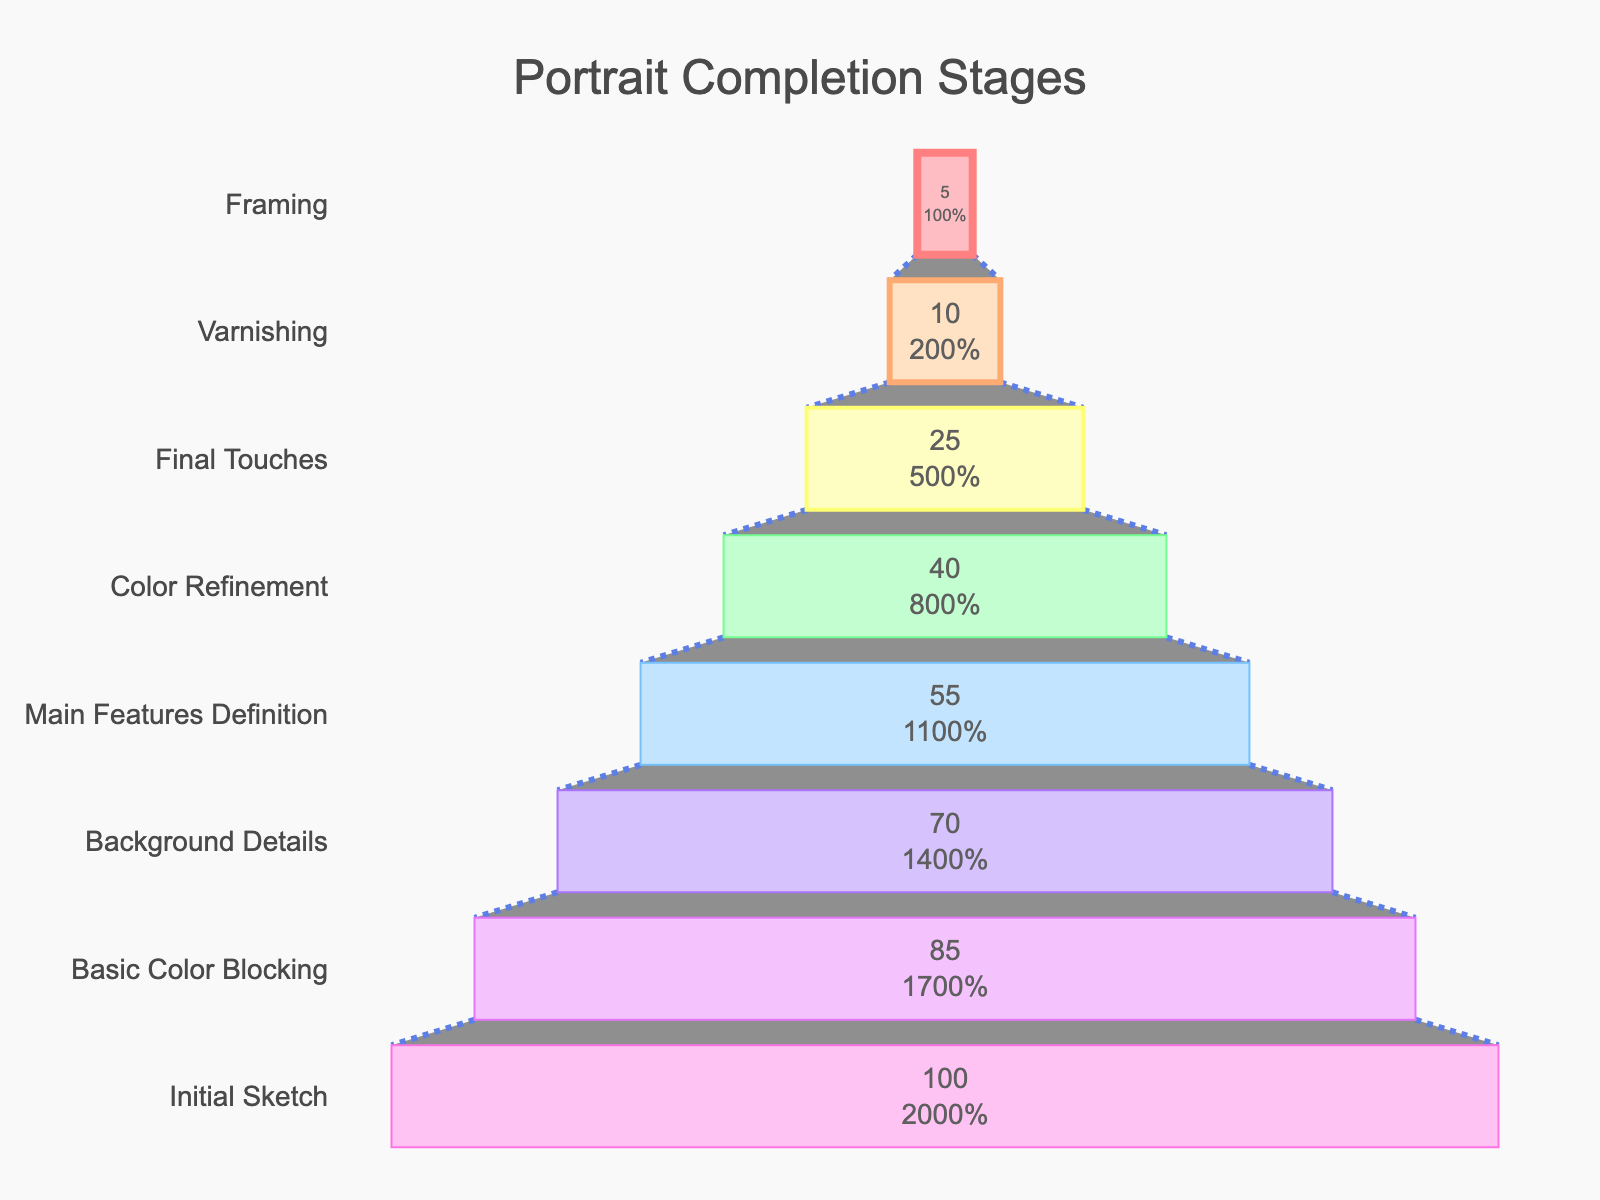How many stages are there in the portrait completion process? The funnel chart lists different stages starting from "Initial Sketch" to "Framing". Count each stage.
Answer: 8 Which stage has the highest percentage completed? The stage with the highest percentage completed is the one at the top of the funnel, labeled "Initial Sketch" with 100% completed.
Answer: Initial Sketch At which stage is the completion percentage closest to 50%? Look at the list of stages and their corresponding completion percentages. The "Main Features Definition" stage has a completion percentage of 55%, which is closest to 50%.
Answer: Main Features Definition How much is the completion percentage reduced from the "Background Details" stage to the "Main Features Definition" stage? The completion percentage at the "Background Details" stage is 70%, and at "Main Features Definition" it is 55%. Subtract 55 from 70 to find the difference.
Answer: 15% Which stage experiences the smallest drop in percentage completion from the previous stage? Compare the percentage drops between each consecutive stage. The drop between "Final Touches" (25%) and "Varnishing" (10%) is the smallest, which is 15%.
Answer: Final Touches to Varnishing What is the sum of the completion percentages for "Final Touches" and "Framing"? Add the completion percentages of the "Final Touches" (25%) and "Framing" (5%) stages together.
Answer: 30% How does the percentage completed for "Color Refinement" compare to that of "Basic Color Blocking"? Compare the percentages of "Color Refinement" (40%) and "Basic Color Blocking" (85%). "Color Refinement" has a lower percentage completed.
Answer: Lower What percentage of the total completeness is lost from the "Basic Color Blocking" stage to the "Final Touches" stage? Start with the "Basic Color Blocking" (85%), and "Final Touches" (25%). Subtract 25 from 85 to get the loss in percentage.
Answer: 60% Which stage involves the most detailed work but shows the least progress percentage-wise? Work that appears detailed is often at later stages. "Framing" has the smallest percentage (5%), indicating the least progress percentage-wise.
Answer: Framing 